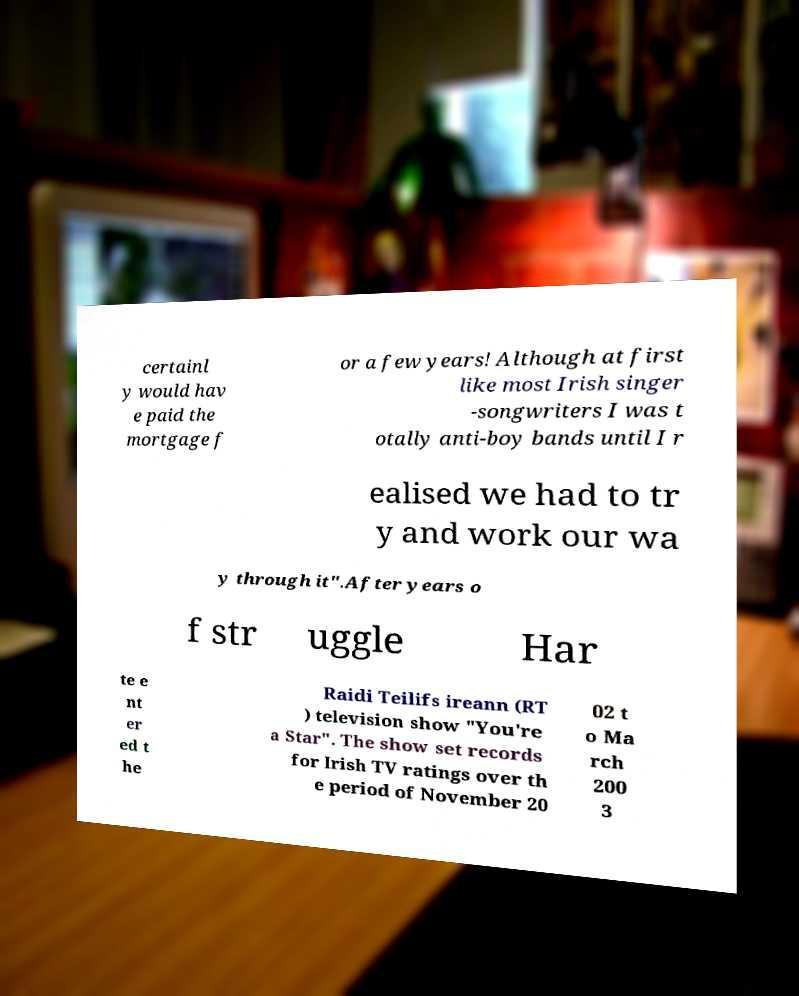I need the written content from this picture converted into text. Can you do that? certainl y would hav e paid the mortgage f or a few years! Although at first like most Irish singer -songwriters I was t otally anti-boy bands until I r ealised we had to tr y and work our wa y through it".After years o f str uggle Har te e nt er ed t he Raidi Teilifs ireann (RT ) television show "You're a Star". The show set records for Irish TV ratings over th e period of November 20 02 t o Ma rch 200 3 